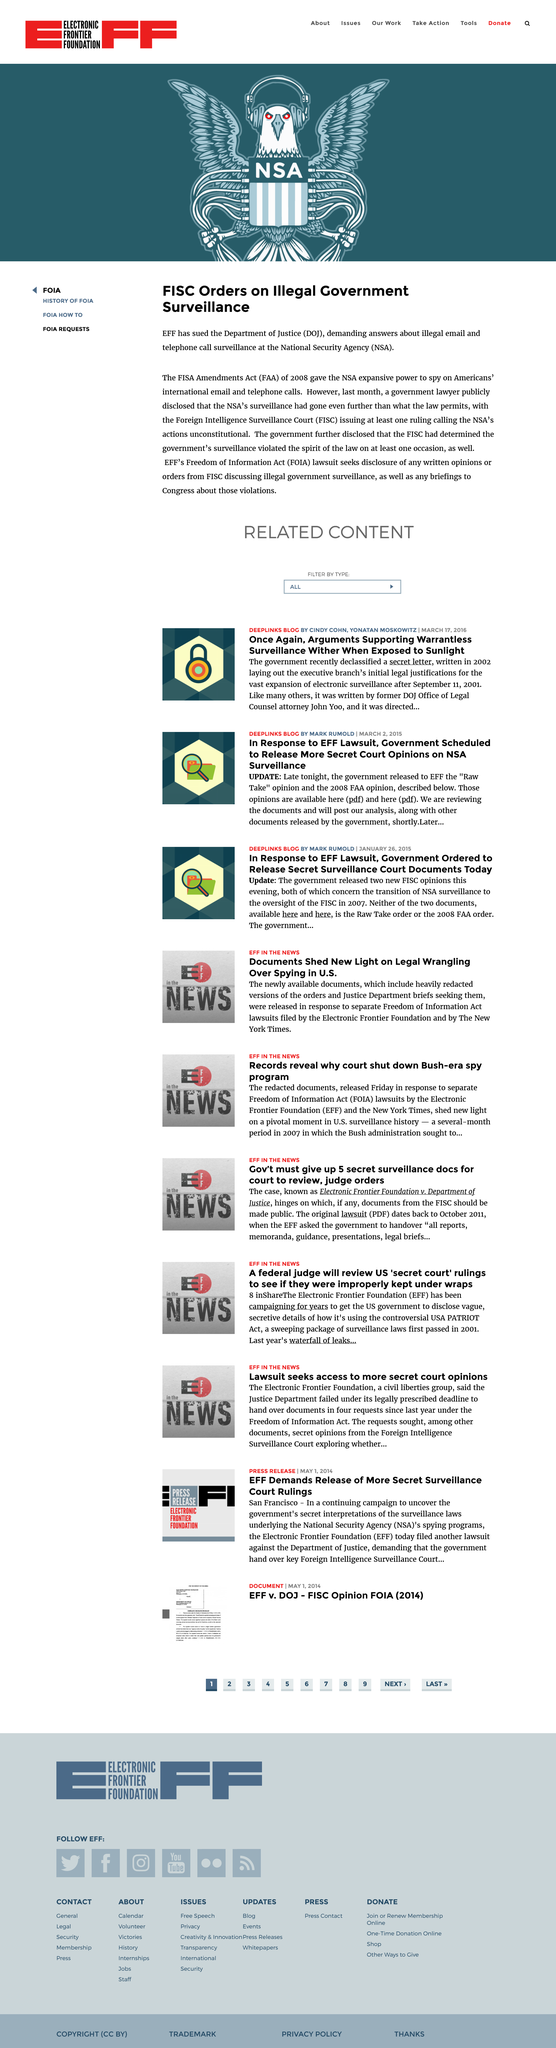Identify some key points in this picture. The acronym "FAA" stands for "FISA Amendments Act. The National Security Agency, commonly known as the NSA, is an agency of the United States government responsible for protecting national security through the collection, analysis, and dissemination of intelligence. The Department of Justice is commonly referred to as DOJ. 